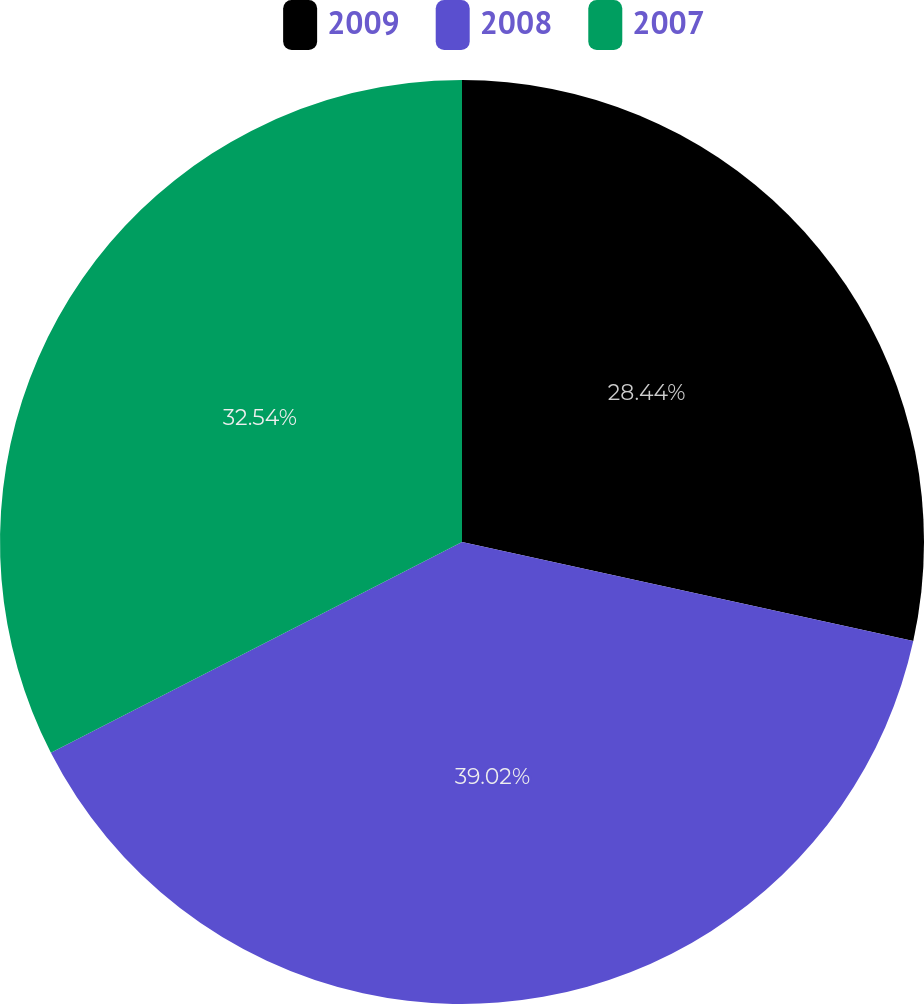Convert chart to OTSL. <chart><loc_0><loc_0><loc_500><loc_500><pie_chart><fcel>2009<fcel>2008<fcel>2007<nl><fcel>28.44%<fcel>39.02%<fcel>32.54%<nl></chart> 